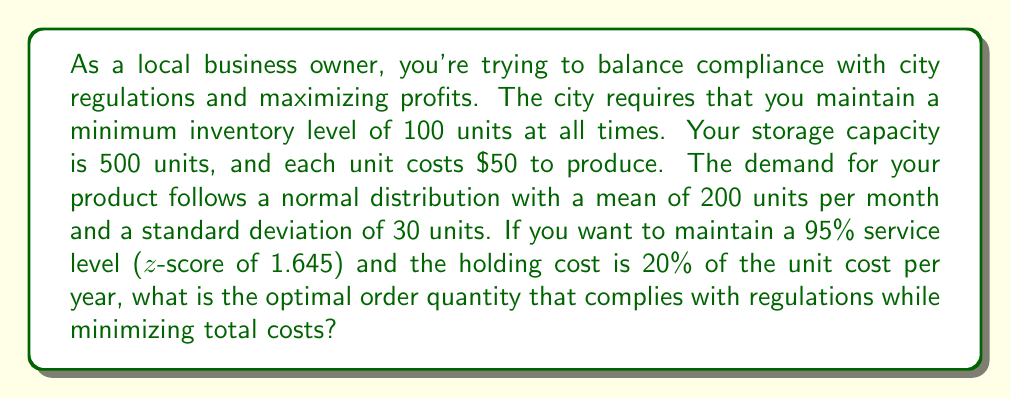Can you solve this math problem? To solve this problem, we'll use the Economic Order Quantity (EOQ) model with a safety stock component to account for the city regulations and desired service level.

1. Calculate the safety stock:
   Safety Stock = z-score × standard deviation
   $SS = 1.645 \times 30 = 49.35$ units

2. Calculate the reorder point (ROP):
   ROP = Average demand during lead time + Safety Stock
   Assuming a 1-month lead time: $ROP = 200 + 49.35 = 249.35$ units

3. Calculate the EOQ using the standard formula:
   $$EOQ = \sqrt{\frac{2 \times D \times S}{H}}$$
   Where:
   D = Annual demand = 200 × 12 = 2400 units
   S = Order cost (assume $100 per order)
   H = Holding cost per unit per year = $50 × 0.20 = $10

   $$EOQ = \sqrt{\frac{2 × 2400 × 100}{10}} = 219.09$$ units

4. Adjust the EOQ to comply with city regulations:
   The minimum inventory level should be 100 units, which is less than our calculated safety stock. Therefore, we don't need to adjust our EOQ for the minimum inventory requirement.

5. Check if the EOQ exceeds storage capacity:
   Maximum inventory level = EOQ + Safety Stock = 219.09 + 49.35 = 268.44 units
   This is well below the 500-unit storage capacity, so no adjustment is needed.

The optimal order quantity that complies with regulations while minimizing total costs is the calculated EOQ of 219.09 units, rounded to the nearest whole number.
Answer: 219 units 